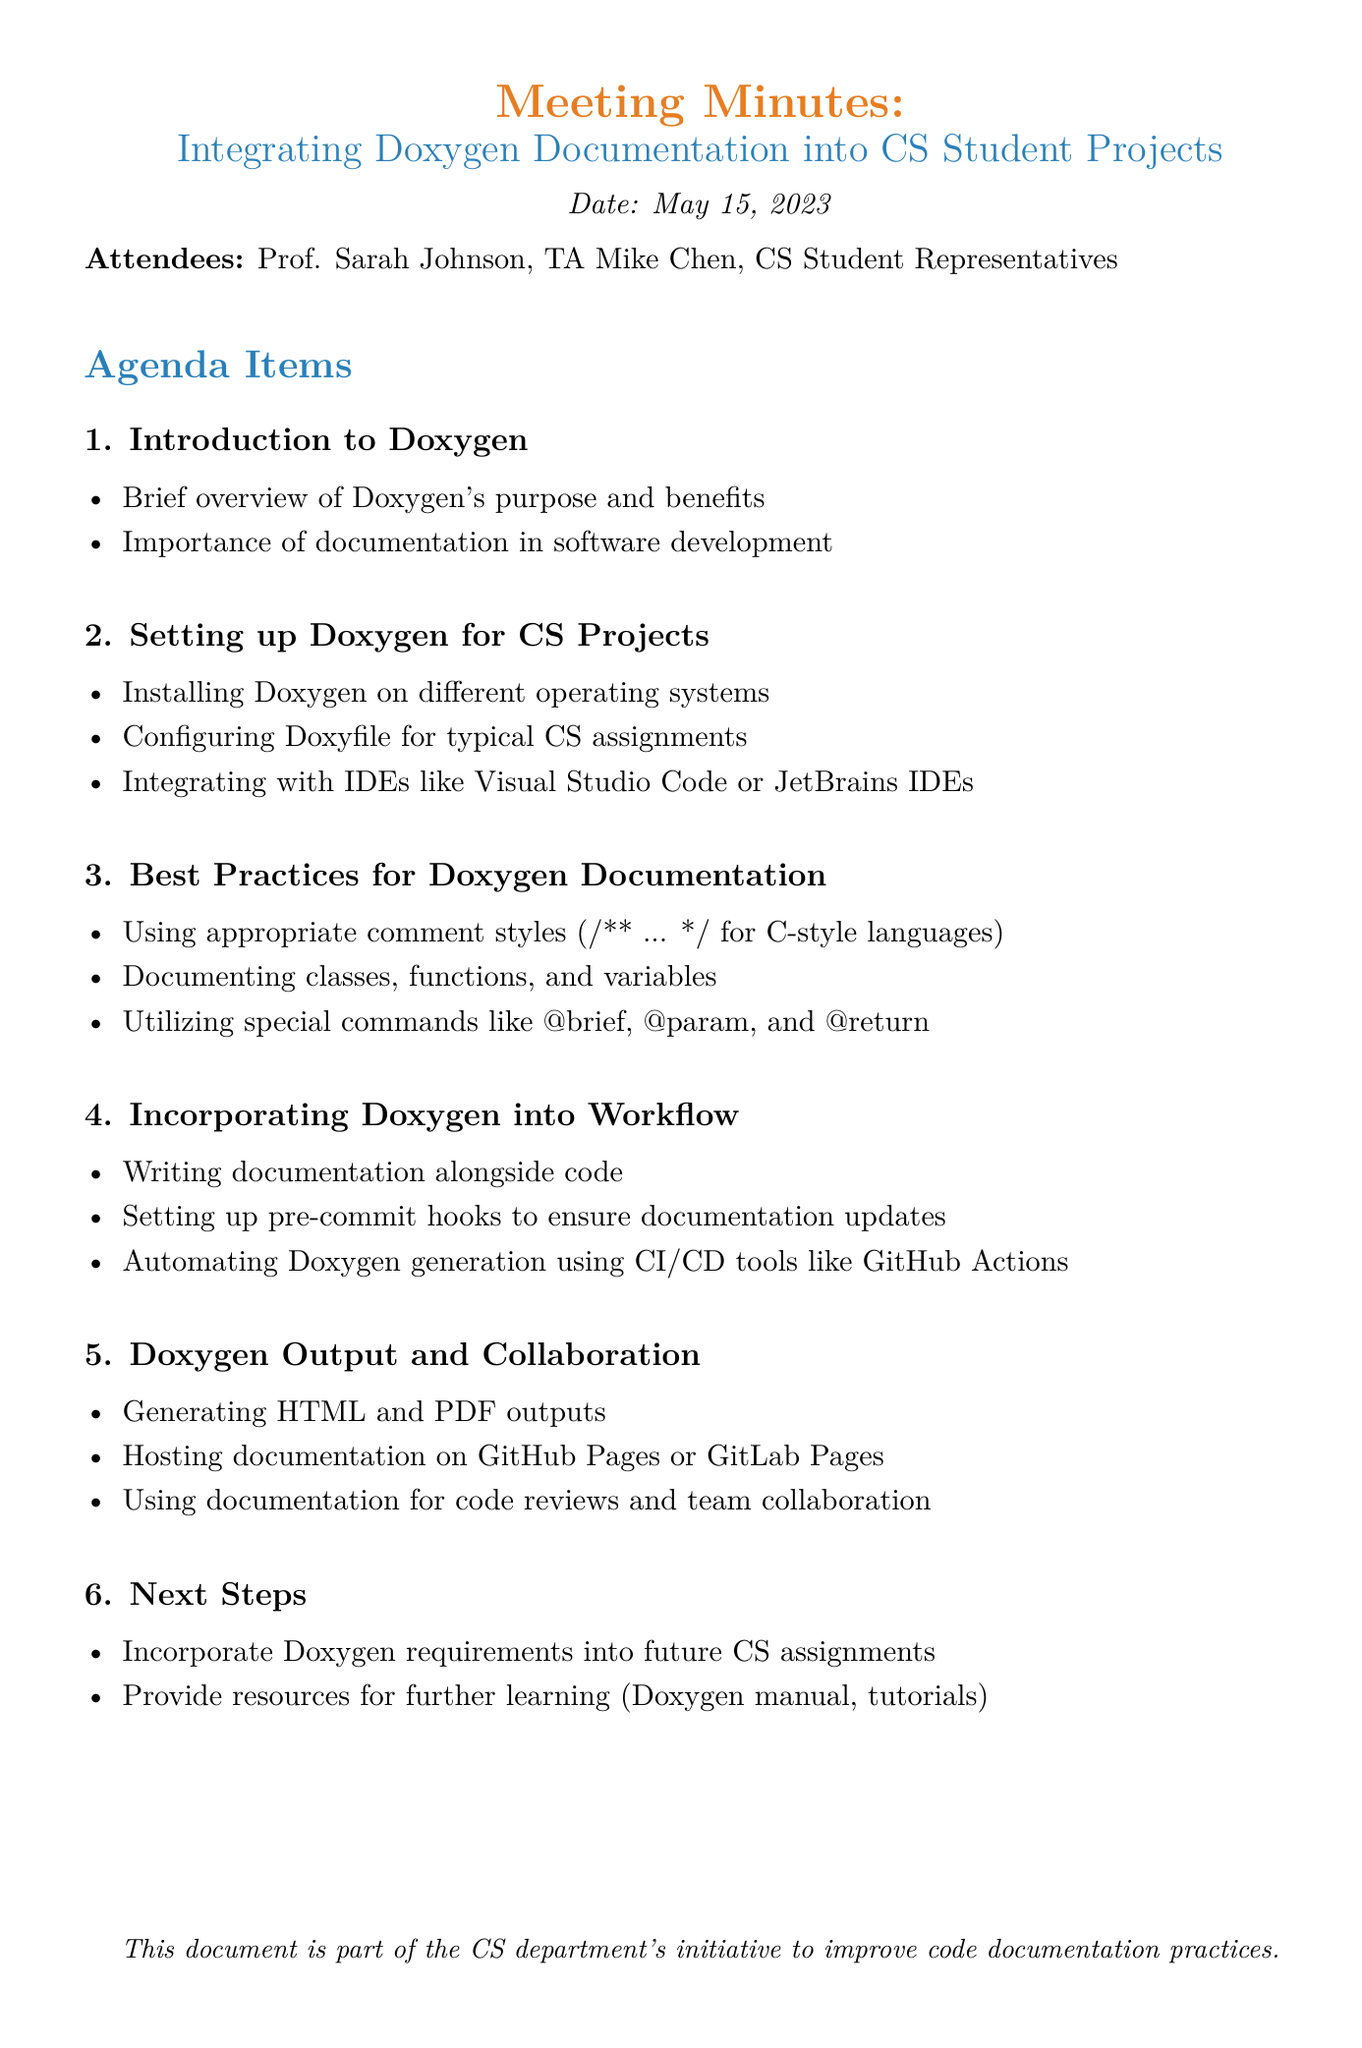What is the meeting date? The document specifies the meeting date as May 15, 2023.
Answer: May 15, 2023 Who is the first attendee listed? The first attendee mentioned in the document is Prof. Sarah Johnson.
Answer: Prof. Sarah Johnson What is the title of the third agenda item? The title of the third agenda item in the document is "Best Practices for Doxygen Documentation."
Answer: Best Practices for Doxygen Documentation Which CI/CD tool is mentioned for automating Doxygen generation? The document mentions GitHub Actions as a CI/CD tool for automating Doxygen generation.
Answer: GitHub Actions What is a suggested output format for Doxygen documentation? The document lists HTML and PDF as output formats for Doxygen documentation.
Answer: HTML and PDF What does the document suggest for ensuring documentation updates? The document suggests setting up pre-commit hooks to ensure documentation updates.
Answer: Pre-commit hooks How many agenda items are listed in the document? There are six agenda items listed in the meeting minutes.
Answer: Six What steps does the document recommend for future assignments? The document recommends incorporating Doxygen requirements into future CS assignments.
Answer: Incorporate Doxygen requirements What is the overall purpose of the meeting as indicated in the title? The meeting's purpose, as indicated in the title, is to discuss integrating Doxygen documentation into CS student projects.
Answer: Integrating Doxygen Documentation into CS Student Projects 